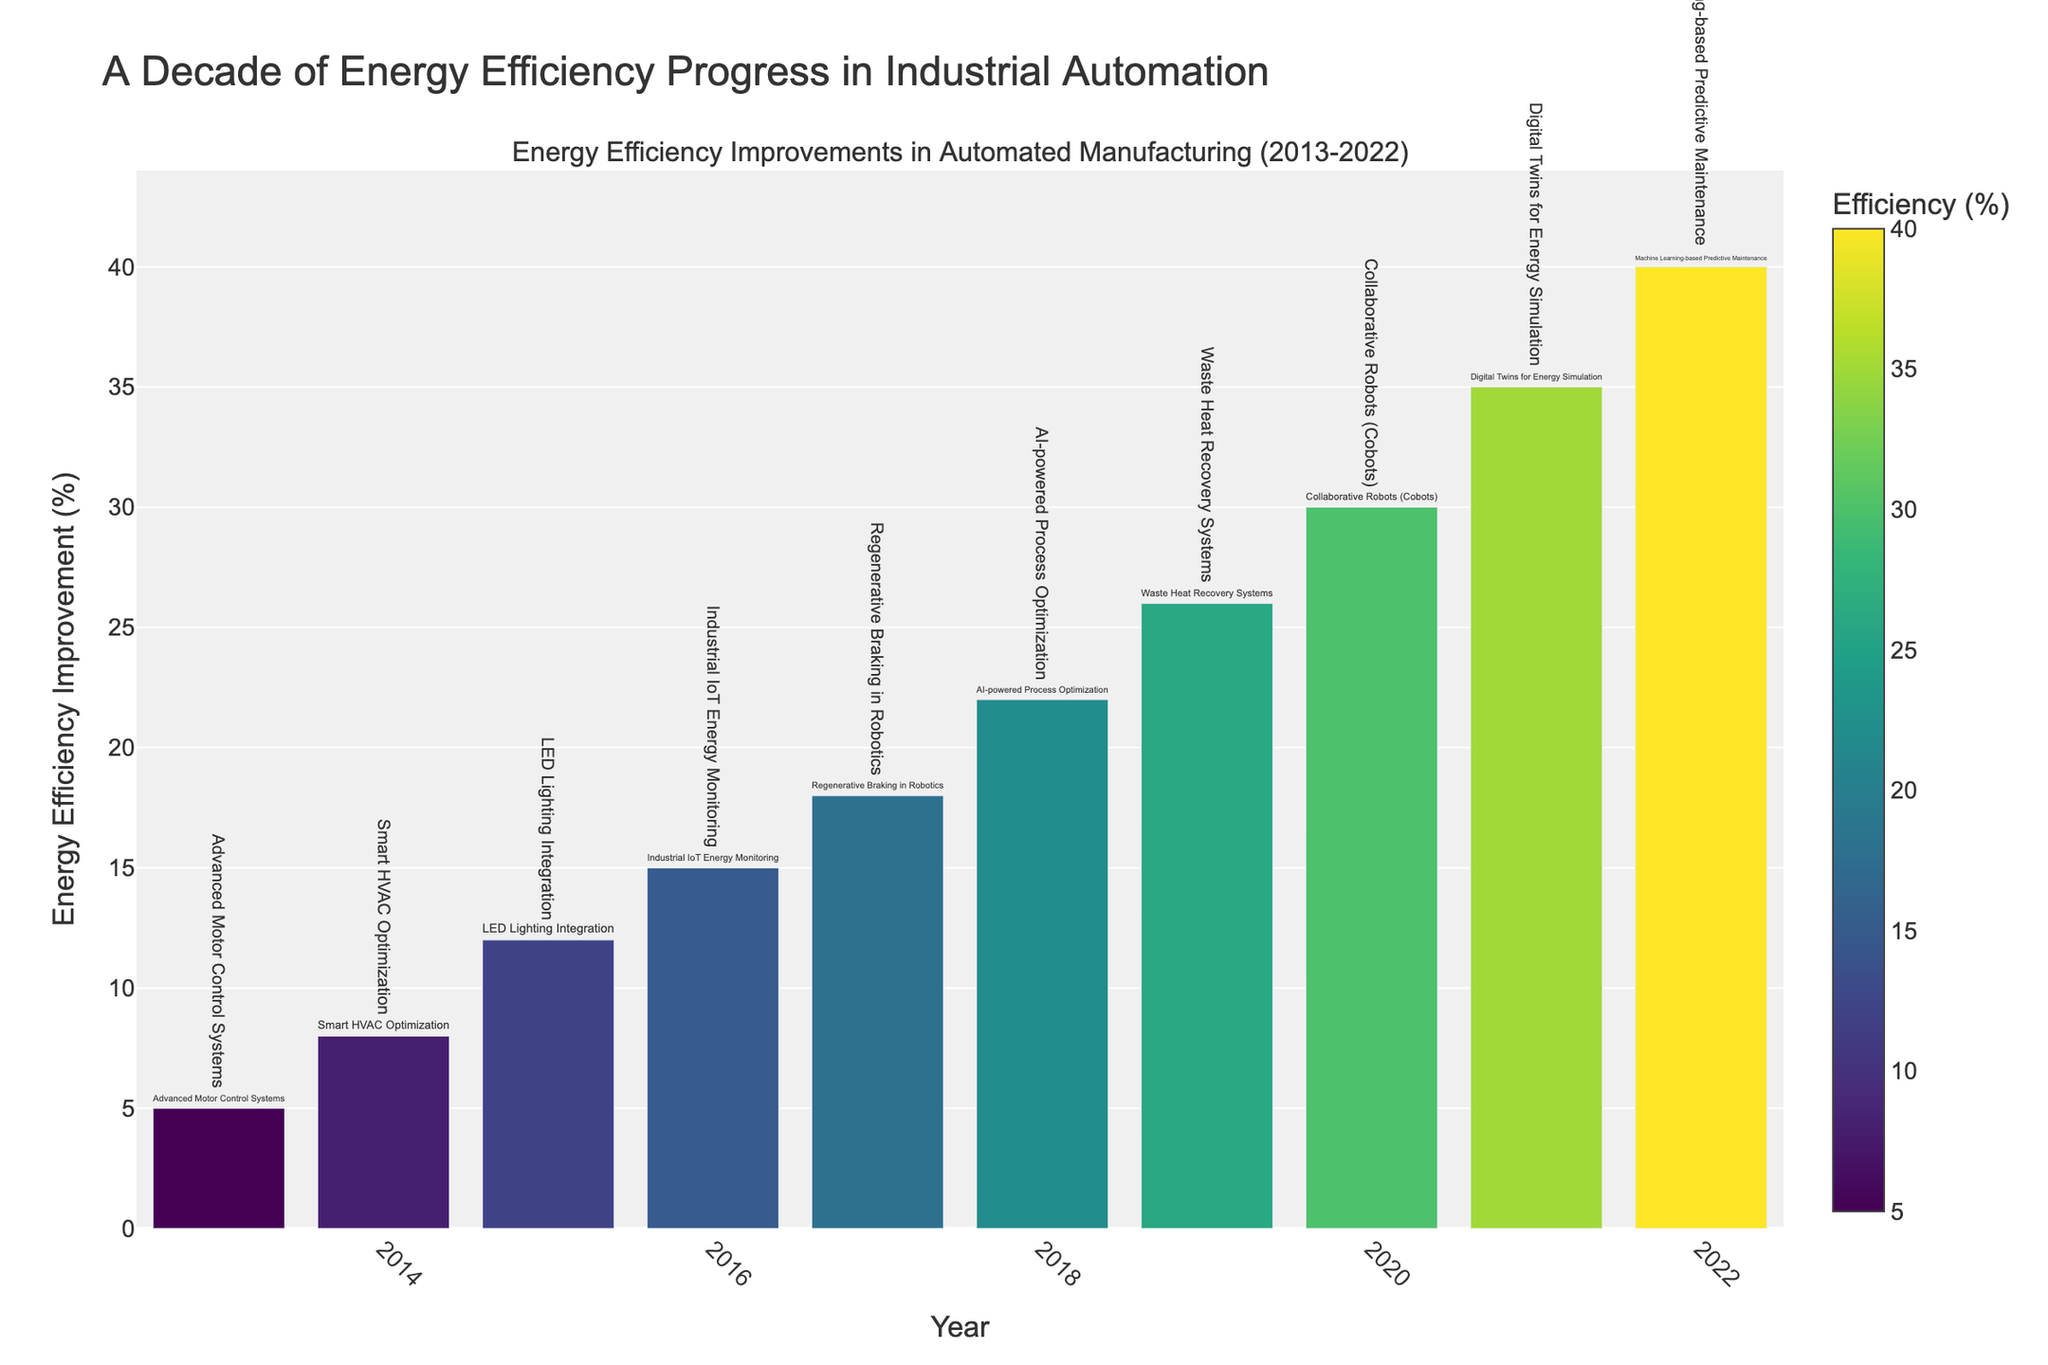What's the highest energy efficiency improvement recorded? To determine the highest energy efficiency improvement, look for the tallest bar or the maximum percentage listed. The year 2022 shows the highest improvement with 40%.
Answer: 40% Which year saw a 15% improvement in energy efficiency? Find the bar labeled with "15%" along the vertical axis. The year associated with this percentage is 2016.
Answer: 2016 What technology was implemented in 2018? Look at the bar corresponding to the year 2018 and read the label provided. The technology implemented in 2018 is AI-powered Process Optimization.
Answer: AI-powered Process Optimization How much did energy efficiency improve from 2017 to 2019? Identify the bars for 2017 and 2019, and note their heights (18% for 2017 and 26% for 2019). Calculate the difference: 26% - 18% = 8%.
Answer: 8% Which technology showed a greater improvement: Advanced Motor Control Systems or Machine Learning-based Predictive Maintenance? Compare the bars for Advanced Motor Control Systems (2013) at 5% and Machine Learning-based Predictive Maintenance (2022) at 40% to see which one has a higher value. Machine Learning-based Predictive Maintenance has a higher improvement at 40%.
Answer: Machine Learning-based Predictive Maintenance What is the average annual energy efficiency improvement from 2013 to 2022? To find the average, sum all the yearly improvements (5% + 8% + 12% + 15% + 18% + 22% + 26% + 30% + 35% + 40% = 211%) and divide by the number of years (10). The average is 211% / 10 = 21.1%.
Answer: 21.1% In which year did energy efficiency improve by the smallest margin compared to the previous year? Calculate the differences between each consecutive year's improvements: 2014-2013 (8%-5%=3%), 2015-2014 (12%-8%=4%), 2016-2015 (15%-12%=3%), 2017-2016 (18%-15%=3%), 2018-2017 (22%-18%=4%), 2019-2018 (26%-22%=4%), 2020-2019 (30%-26%=4%), 2021-2020 (35%-30%=5%), 2022-2021 (40%-35%=5%). The smallest margin is between 2013-2014, 2015-2016, and 2016-2017 with 3%.
Answer: 2014, 2016, 2017 Which year experienced the second highest improvement in energy efficiency? Find the second tallest bar after the 2022 bar (40%). The 2021 bar shows 35%, which is the second highest.
Answer: 2021 What is the range of energy efficiency improvements observed over the decade? Calculate the range by finding the difference between the maximum and minimum improvements: 40% (2022) - 5% (2013) = 35%.
Answer: 35% How many years had an energy efficiency improvement of 20% or more? Count the bars with heights of 20% or more: 2018 (22%), 2019 (26%), 2020 (30%), 2021 (35%), and 2022 (40%). There are 5 such years.
Answer: 5 